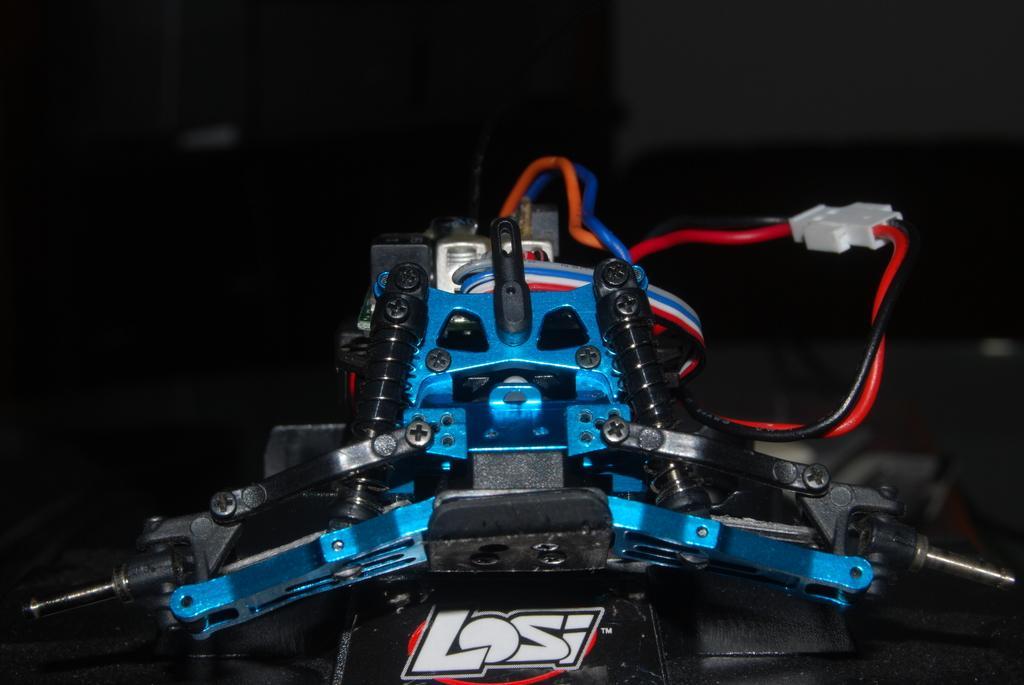How would you summarize this image in a sentence or two? This is the picture of a electronic device to which there are some wires and some other objects. 